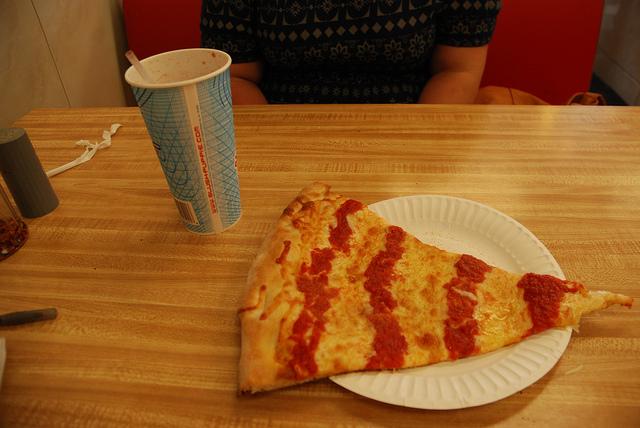What pattern is on the pizza?
Answer briefly. Stripes. What type of pizza is this?
Concise answer only. Cheese. What is in the gray container on the right?
Keep it brief. Pepper. 